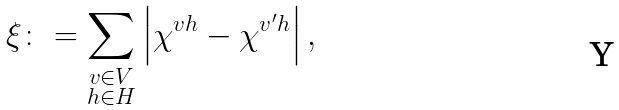Convert formula to latex. <formula><loc_0><loc_0><loc_500><loc_500>\xi \colon = \sum _ { \substack { v \in V \\ h \in H } } \left | \chi ^ { v h } - \chi ^ { v ^ { \prime } h } \right | ,</formula> 